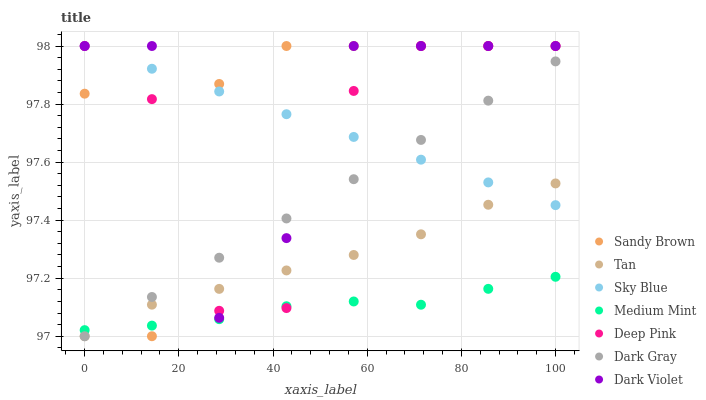Does Medium Mint have the minimum area under the curve?
Answer yes or no. Yes. Does Sandy Brown have the maximum area under the curve?
Answer yes or no. Yes. Does Deep Pink have the minimum area under the curve?
Answer yes or no. No. Does Deep Pink have the maximum area under the curve?
Answer yes or no. No. Is Sky Blue the smoothest?
Answer yes or no. Yes. Is Dark Violet the roughest?
Answer yes or no. Yes. Is Deep Pink the smoothest?
Answer yes or no. No. Is Deep Pink the roughest?
Answer yes or no. No. Does Dark Gray have the lowest value?
Answer yes or no. Yes. Does Deep Pink have the lowest value?
Answer yes or no. No. Does Sandy Brown have the highest value?
Answer yes or no. Yes. Does Dark Gray have the highest value?
Answer yes or no. No. Is Medium Mint less than Dark Violet?
Answer yes or no. Yes. Is Sky Blue greater than Medium Mint?
Answer yes or no. Yes. Does Sky Blue intersect Dark Violet?
Answer yes or no. Yes. Is Sky Blue less than Dark Violet?
Answer yes or no. No. Is Sky Blue greater than Dark Violet?
Answer yes or no. No. Does Medium Mint intersect Dark Violet?
Answer yes or no. No. 